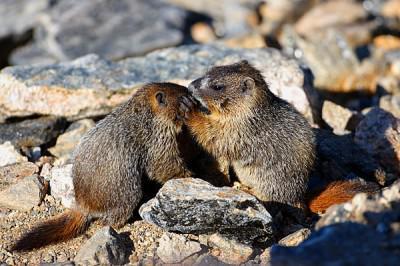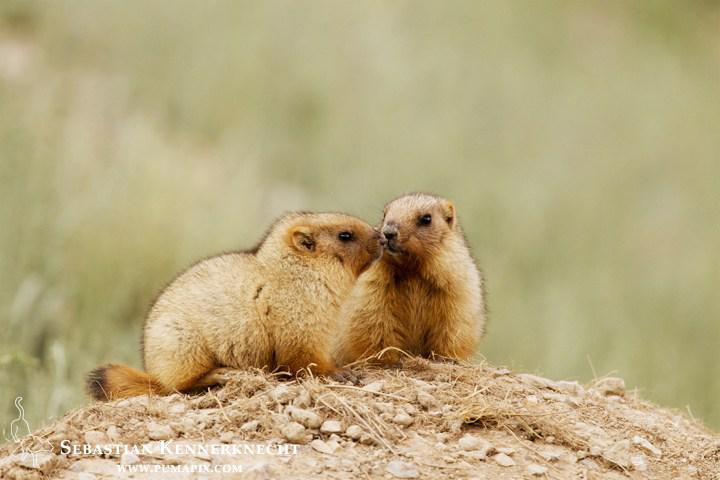The first image is the image on the left, the second image is the image on the right. Evaluate the accuracy of this statement regarding the images: "There are two brown furry little animals outside.". Is it true? Answer yes or no. No. 